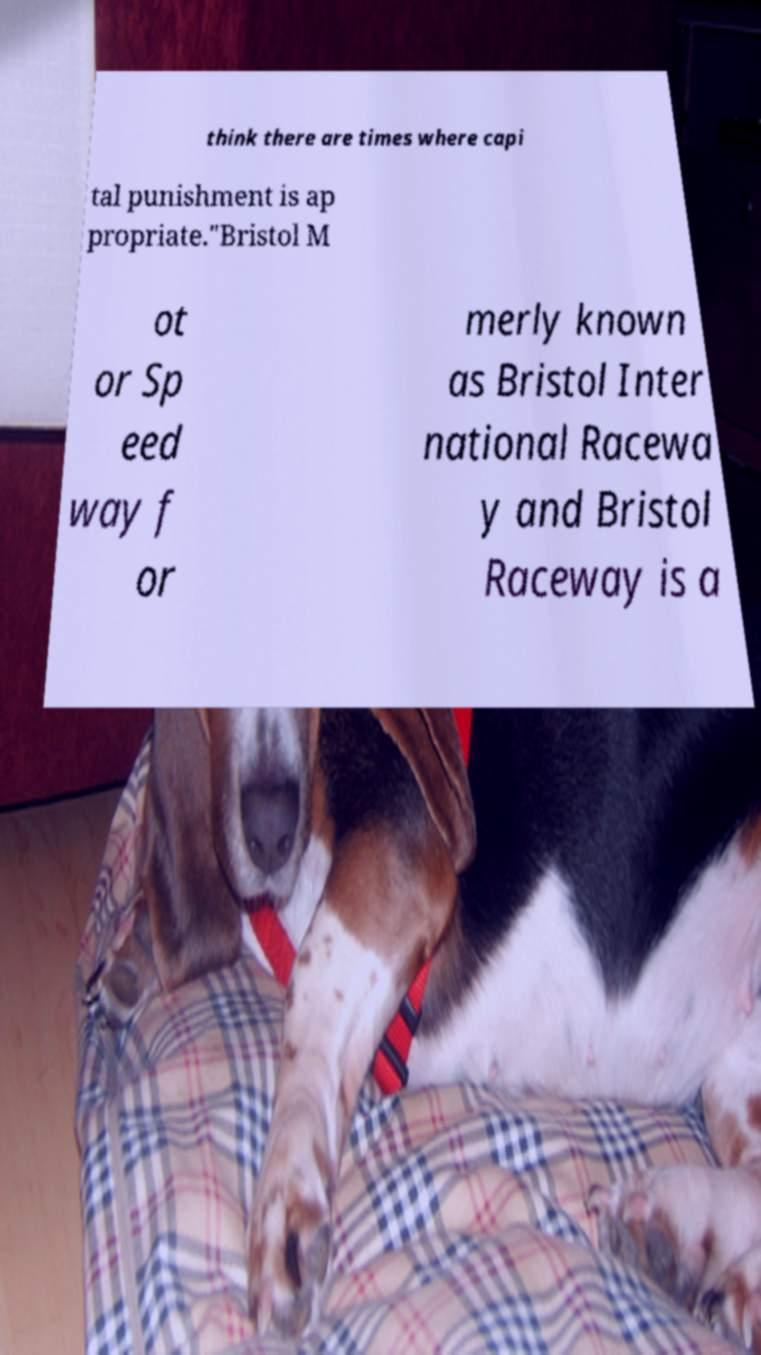What messages or text are displayed in this image? I need them in a readable, typed format. think there are times where capi tal punishment is ap propriate."Bristol M ot or Sp eed way f or merly known as Bristol Inter national Racewa y and Bristol Raceway is a 